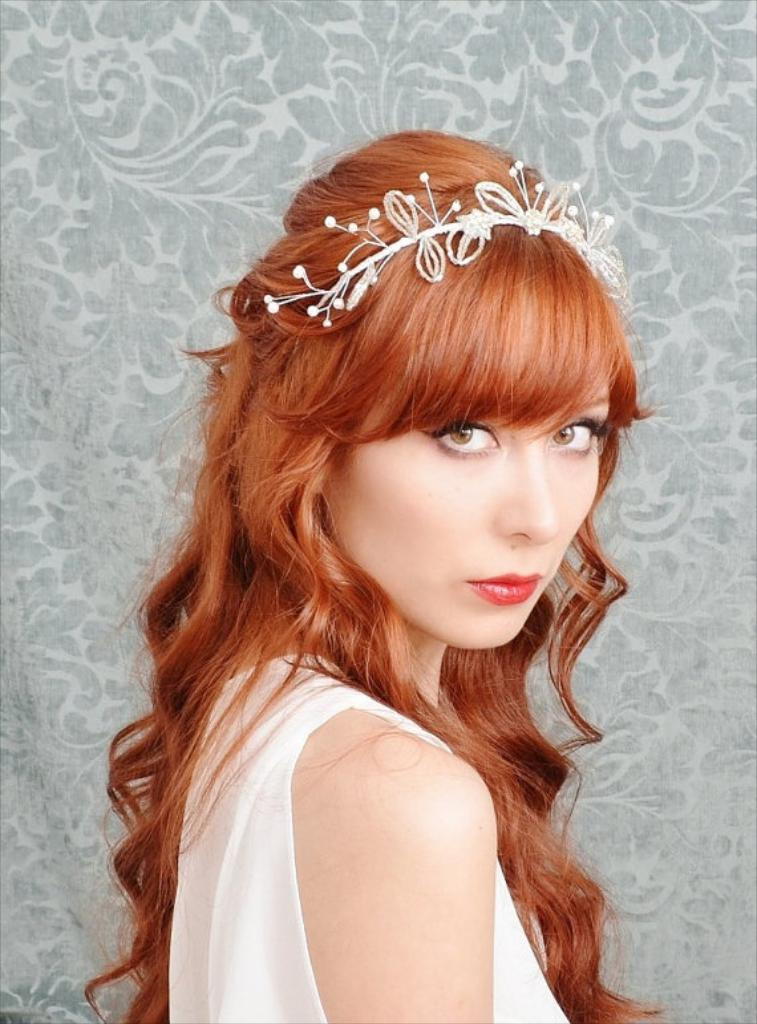What is the main subject of the image? There is a beautiful woman in the image. What is the woman doing in the image? The woman is looking at the side. What is the woman wearing in the image? The woman is wearing a white dress. What color is the woman's hair in the image? The woman's hair is brown. What type of fish is the woman holding in the image? There is no fish present in the image; the woman is not holding anything. What kind of business is the woman conducting in the image? There is no indication of any business activity in the image; the woman is simply looking at the side. 